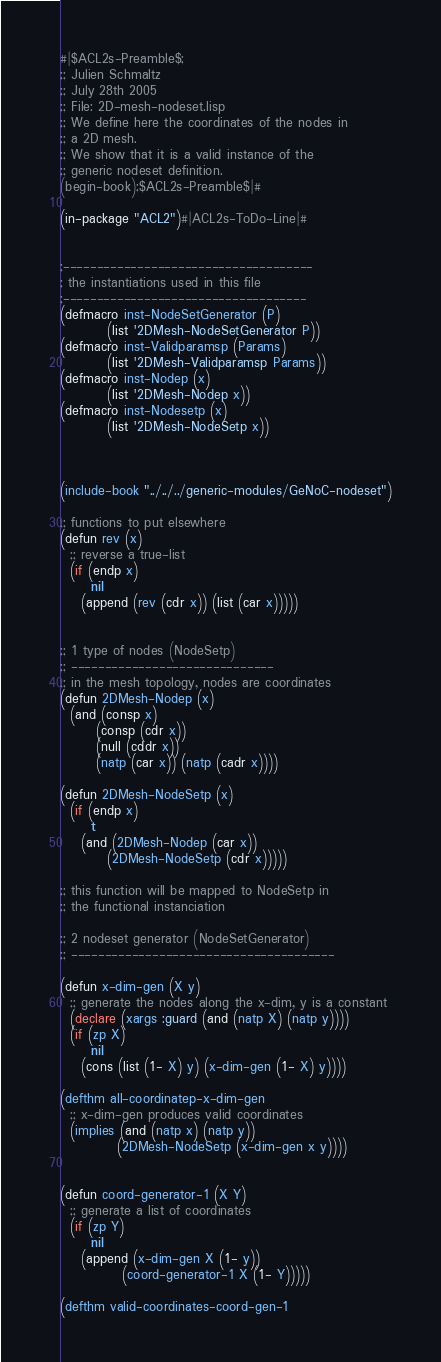<code> <loc_0><loc_0><loc_500><loc_500><_Lisp_>#|$ACL2s-Preamble$;
;; Julien Schmaltz
;; July 28th 2005
;; File: 2D-mesh-nodeset.lisp
;; We define here the coordinates of the nodes in
;; a 2D mesh.
;; We show that it is a valid instance of the
;; generic nodeset definition.
(begin-book);$ACL2s-Preamble$|#

(in-package "ACL2")#|ACL2s-ToDo-Line|#


;-------------------------------------
; the instantiations used in this file
;------------------------------------
(defmacro inst-NodeSetGenerator (P)
         (list '2DMesh-NodeSetGenerator P))
(defmacro inst-Validparamsp (Params)
         (list '2DMesh-Validparamsp Params))
(defmacro inst-Nodep (x)
         (list '2DMesh-Nodep x))
(defmacro inst-Nodesetp (x)
         (list '2DMesh-NodeSetp x))



(include-book "../../../generic-modules/GeNoC-nodeset")

;; functions to put elsewhere
(defun rev (x)
  ;; reverse a true-list
  (if (endp x)
      nil
    (append (rev (cdr x)) (list (car x)))))


;; 1 type of nodes (NodeSetp)
;; ------------------------------
;; in the mesh topology, nodes are coordinates
(defun 2DMesh-Nodep (x)
  (and (consp x)
       (consp (cdr x))
       (null (cddr x))
       (natp (car x)) (natp (cadr x))))

(defun 2DMesh-NodeSetp (x)
  (if (endp x)
      t
    (and (2DMesh-Nodep (car x))
         (2DMesh-NodeSetp (cdr x)))))

;; this function will be mapped to NodeSetp in
;; the functional instanciation

;; 2 nodeset generator (NodeSetGenerator)
;; ---------------------------------------

(defun x-dim-gen (X y)
  ;; generate the nodes along the x-dim, y is a constant
  (declare (xargs :guard (and (natp X) (natp y))))
  (if (zp X)
      nil
    (cons (list (1- X) y) (x-dim-gen (1- X) y))))

(defthm all-coordinatep-x-dim-gen
  ;; x-dim-gen produces valid coordinates
  (implies (and (natp x) (natp y))
           (2DMesh-NodeSetp (x-dim-gen x y))))


(defun coord-generator-1 (X Y)
  ;; generate a list of coordinates
  (if (zp Y)
      nil
    (append (x-dim-gen X (1- y))
            (coord-generator-1 X (1- Y)))))

(defthm valid-coordinates-coord-gen-1</code> 